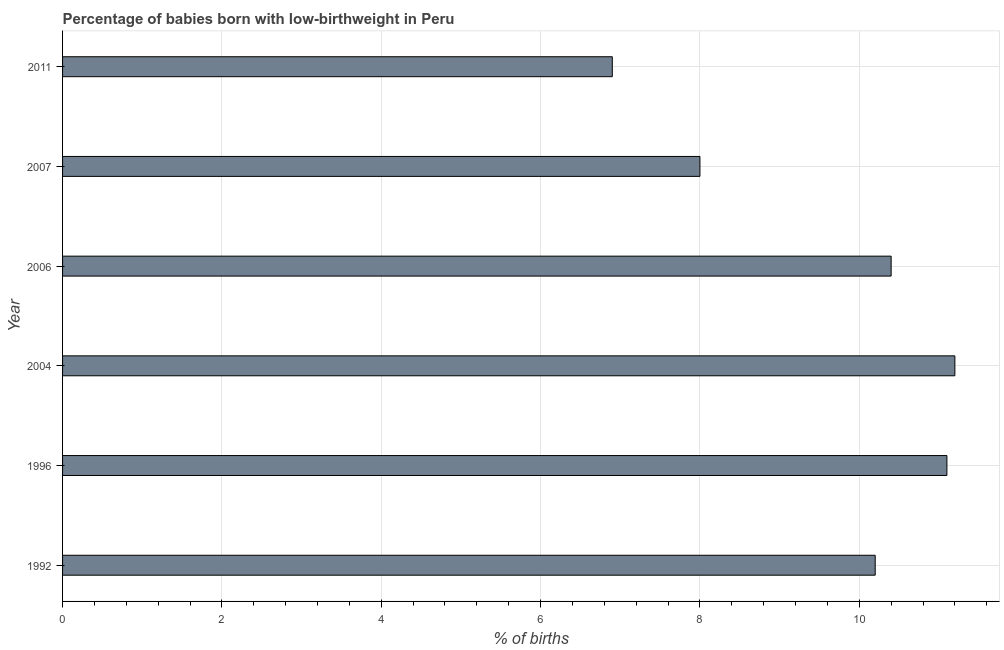Does the graph contain any zero values?
Offer a very short reply. No. Does the graph contain grids?
Give a very brief answer. Yes. What is the title of the graph?
Offer a very short reply. Percentage of babies born with low-birthweight in Peru. What is the label or title of the X-axis?
Keep it short and to the point. % of births. What is the label or title of the Y-axis?
Make the answer very short. Year. What is the percentage of babies who were born with low-birthweight in 2006?
Offer a terse response. 10.4. In which year was the percentage of babies who were born with low-birthweight maximum?
Provide a short and direct response. 2004. What is the sum of the percentage of babies who were born with low-birthweight?
Keep it short and to the point. 57.8. What is the difference between the percentage of babies who were born with low-birthweight in 1992 and 2006?
Provide a succinct answer. -0.2. What is the average percentage of babies who were born with low-birthweight per year?
Offer a terse response. 9.63. Do a majority of the years between 2011 and 2007 (inclusive) have percentage of babies who were born with low-birthweight greater than 10.4 %?
Offer a very short reply. No. What is the ratio of the percentage of babies who were born with low-birthweight in 1996 to that in 2006?
Offer a terse response. 1.07. Is the percentage of babies who were born with low-birthweight in 2007 less than that in 2011?
Offer a very short reply. No. How many bars are there?
Keep it short and to the point. 6. Are all the bars in the graph horizontal?
Your response must be concise. Yes. What is the difference between two consecutive major ticks on the X-axis?
Give a very brief answer. 2. Are the values on the major ticks of X-axis written in scientific E-notation?
Offer a very short reply. No. What is the % of births in 1992?
Give a very brief answer. 10.2. What is the % of births in 1996?
Offer a very short reply. 11.1. What is the % of births of 2004?
Your response must be concise. 11.2. What is the % of births in 2007?
Provide a succinct answer. 8. What is the % of births in 2011?
Provide a short and direct response. 6.9. What is the difference between the % of births in 1992 and 1996?
Your response must be concise. -0.9. What is the difference between the % of births in 1992 and 2004?
Your response must be concise. -1. What is the difference between the % of births in 1992 and 2007?
Ensure brevity in your answer.  2.2. What is the difference between the % of births in 1992 and 2011?
Make the answer very short. 3.3. What is the difference between the % of births in 1996 and 2006?
Your answer should be very brief. 0.7. What is the difference between the % of births in 1996 and 2011?
Your answer should be compact. 4.2. What is the difference between the % of births in 2004 and 2006?
Ensure brevity in your answer.  0.8. What is the difference between the % of births in 2004 and 2007?
Your answer should be compact. 3.2. What is the difference between the % of births in 2006 and 2007?
Offer a terse response. 2.4. What is the difference between the % of births in 2006 and 2011?
Your response must be concise. 3.5. What is the difference between the % of births in 2007 and 2011?
Provide a succinct answer. 1.1. What is the ratio of the % of births in 1992 to that in 1996?
Keep it short and to the point. 0.92. What is the ratio of the % of births in 1992 to that in 2004?
Make the answer very short. 0.91. What is the ratio of the % of births in 1992 to that in 2006?
Make the answer very short. 0.98. What is the ratio of the % of births in 1992 to that in 2007?
Keep it short and to the point. 1.27. What is the ratio of the % of births in 1992 to that in 2011?
Provide a succinct answer. 1.48. What is the ratio of the % of births in 1996 to that in 2004?
Give a very brief answer. 0.99. What is the ratio of the % of births in 1996 to that in 2006?
Your answer should be very brief. 1.07. What is the ratio of the % of births in 1996 to that in 2007?
Give a very brief answer. 1.39. What is the ratio of the % of births in 1996 to that in 2011?
Offer a very short reply. 1.61. What is the ratio of the % of births in 2004 to that in 2006?
Ensure brevity in your answer.  1.08. What is the ratio of the % of births in 2004 to that in 2007?
Offer a very short reply. 1.4. What is the ratio of the % of births in 2004 to that in 2011?
Give a very brief answer. 1.62. What is the ratio of the % of births in 2006 to that in 2007?
Provide a short and direct response. 1.3. What is the ratio of the % of births in 2006 to that in 2011?
Provide a short and direct response. 1.51. What is the ratio of the % of births in 2007 to that in 2011?
Your answer should be compact. 1.16. 